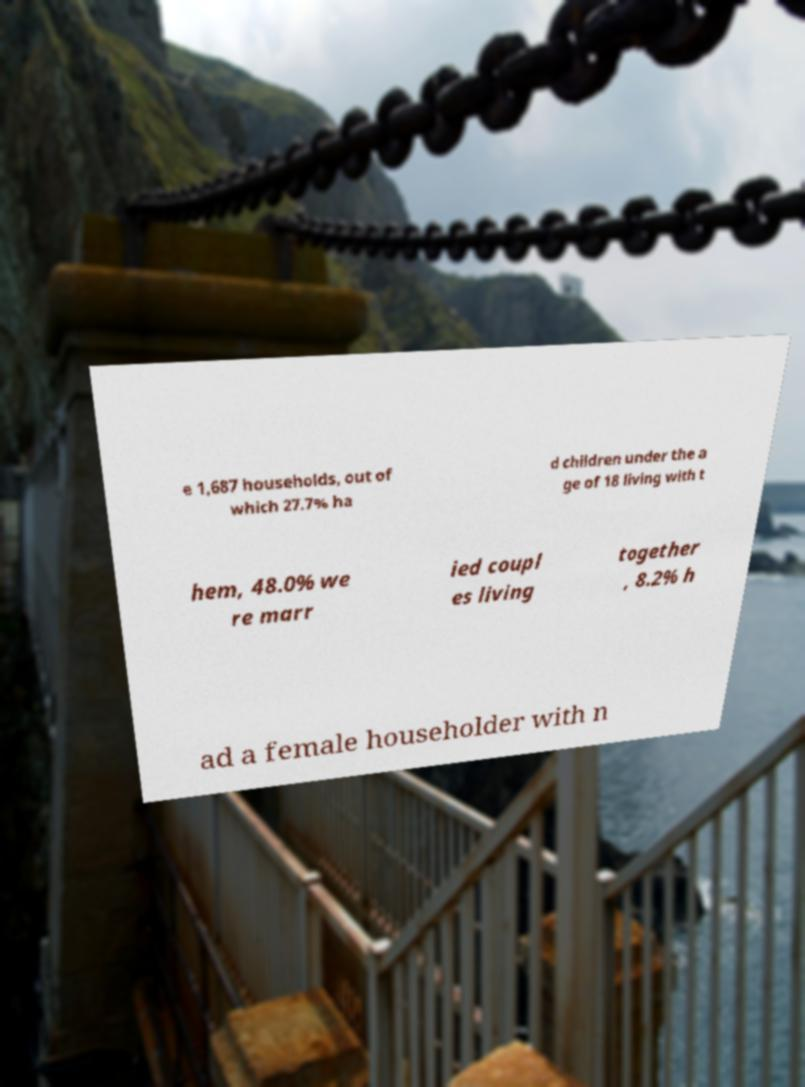Can you read and provide the text displayed in the image?This photo seems to have some interesting text. Can you extract and type it out for me? e 1,687 households, out of which 27.7% ha d children under the a ge of 18 living with t hem, 48.0% we re marr ied coupl es living together , 8.2% h ad a female householder with n 